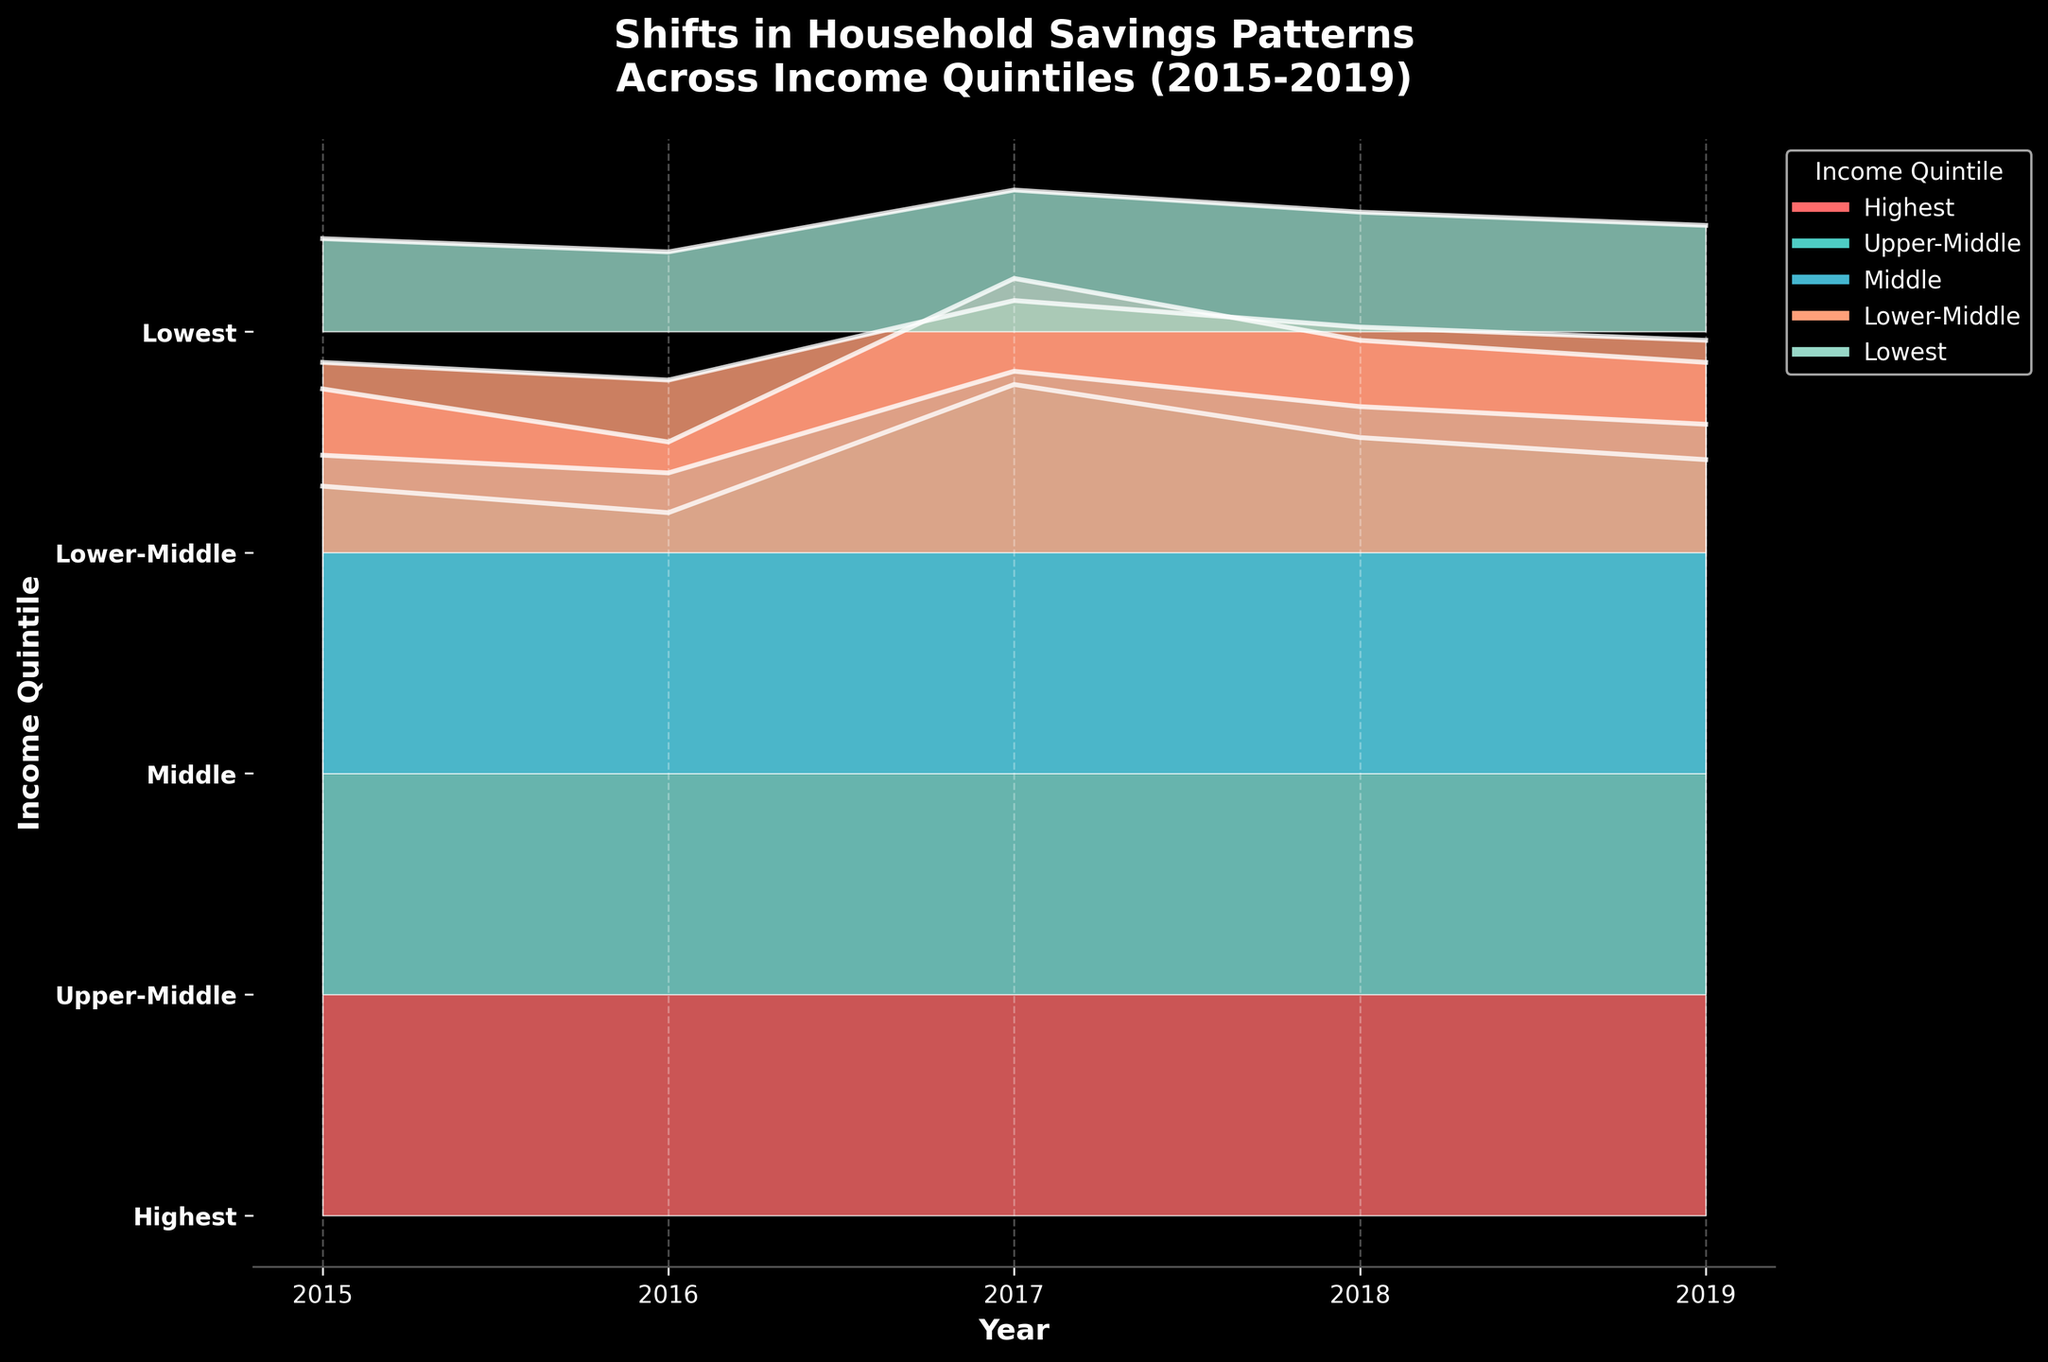What is the title of the figure? The title is usually located at the top of the figure and provides a brief description of what the figure is showing. Here, the title should be at the top, in a larger font size, and it reads: "Shifts in Household Savings Patterns Across Income Quintiles (2015-2019)"
Answer: Shifts in Household Savings Patterns Across Income Quintiles (2015-2019) Which year shows the highest percentage of savings for the highest income quintile? To find the highest percentage of savings for the highest income quintile, look for the peak value in the plot for the "Highest" income quintile line. The highest point should occur at one specific year, and according to the data, it's in 2017.
Answer: 2017 How do the savings percentages of the lowest income quintile change from 2015 to 2019? To understand the change, look at the values for the "Lowest" income quintile across the years. The savings percentage starts at 2.1% in 2015, dips to 1.8% in 2016, peaks to 3.2% in 2017, then gradually decreases to 2.7% in 2018 and 2.4% in 2019.
Answer: Decrease, increase, decrease What is the general trend in savings percentages for the middle-income quintile from 2015 to 2019? Examine the plot for the "Middle" income quintile and observe how the savings percentages change over the years. The trend shows an initial decline in 2016, followed by a rise in 2017, which then slightly drops but stabilizes afterward. From the data, the values are 7.2%, 6.8%, 9.1%, 8.3%, and 7.9% respectively.
Answer: Fluctuating with an overall subtle decline Which income quintile shows the smallest fluctuation in savings percentages from 2015 to 2019? Compare the smoothness and range of the curves for each quintile. The "Highest" income quintile, having more stable fluctuations with the least deviation over the years (from 18.7% to 19.3%), shows the smallest fluctuation in savings percentages.
Answer: Highest For which income quintile did savings percentages increase the most between 2016 and 2017? Look at the rise in the lines from 2016 to 2017 for each quintile. The "Lowest" income quintile shows a significant steep increase from 1.8% in 2016 to 3.2% in 2017, indicating the largest increase.
Answer: Lowest Which income quintile had the highest savings percentage in 2018? Look at the right-most part of the graph for the year 2018 and identify the quintile with the highest point. According to the plot, the "Highest" income quintile has the top value with 19.8% in 2018.
Answer: Highest What was the savings percentage of the lower-middle-income quintile in 2016? To find the specific value, follow the line or ridge labeled "Lower-Middle" to the year 2016. The plot shows this value at around 3.9%.
Answer: 3.9% Which two income quintiles had savings percentages that were closest to each other in 2019? Compare the values for all quintiles in 2019 and identify the two with the smallest difference. The "Middle" and "Lower-Middle" quintiles have closest percentages, with values 7.9% and 4.8% respectively.
Answer: Middle and Lower-Middle What overall pattern can be inferred about the impact of demonetization on household savings among different income quintiles? Reading the data visually, 2016 shows a slight drop for most quintiles, suggesting some negative impact of demonetization. However, post-2016, a notable rebound and fluctuation in savings can be observed, especially in 2017, which implies varied recovery dynamics among different income levels.
Answer: Drop in 2016, rebound in 2017 